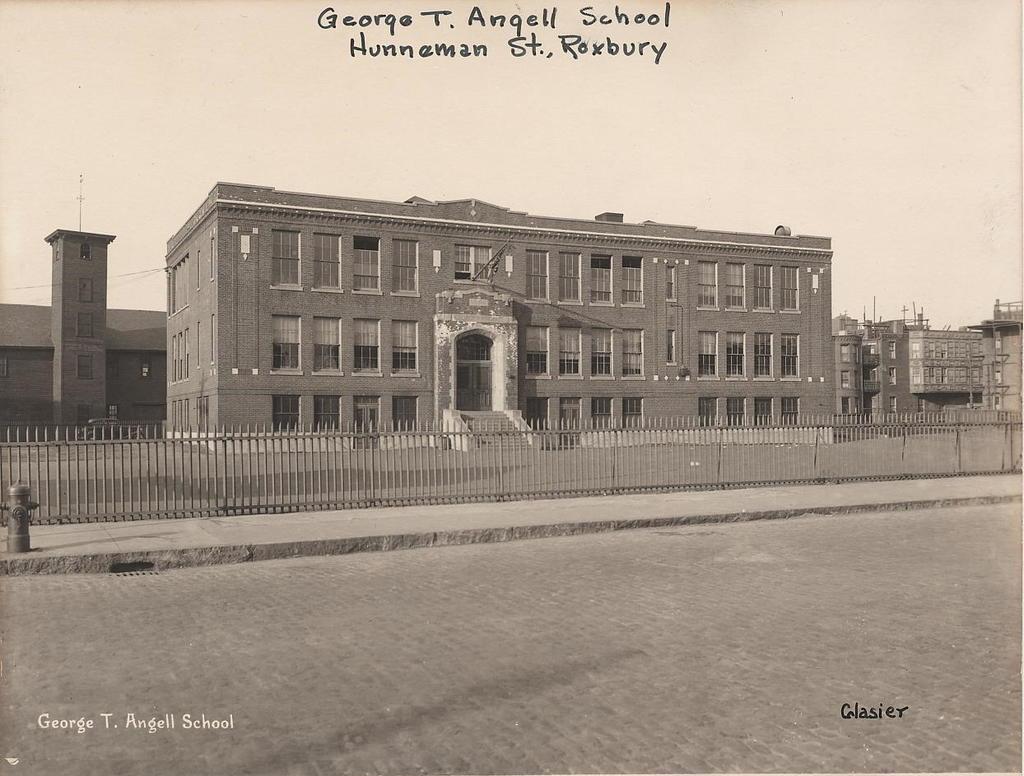Can you describe this image briefly? This is a black and white picture. In the foreground it is road. In the center of the picture there are buildings, railing and footpath. Sky is sunny. At the top there is text. 